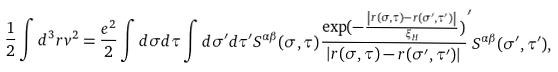Convert formula to latex. <formula><loc_0><loc_0><loc_500><loc_500>\frac { 1 } { 2 } \int d ^ { 3 } r v ^ { 2 } = \frac { e ^ { 2 } } { 2 } \int d \sigma d \tau \int d \sigma ^ { \prime } d \tau ^ { \prime } S ^ { \alpha \beta } ( \sigma , \tau ) \frac { \exp ( - \frac { \left | r ( \sigma , \tau ) - r ( \sigma ^ { \prime } , \tau ^ { \prime } ) \right | } { \xi _ { H } } ) } { \left | r ( \sigma , \tau ) - r ( \sigma ^ { \prime } , \tau ^ { \prime } ) \right | } ^ { \prime } S ^ { \alpha \beta } ( \sigma ^ { \prime } , \tau ^ { \prime } ) ,</formula> 